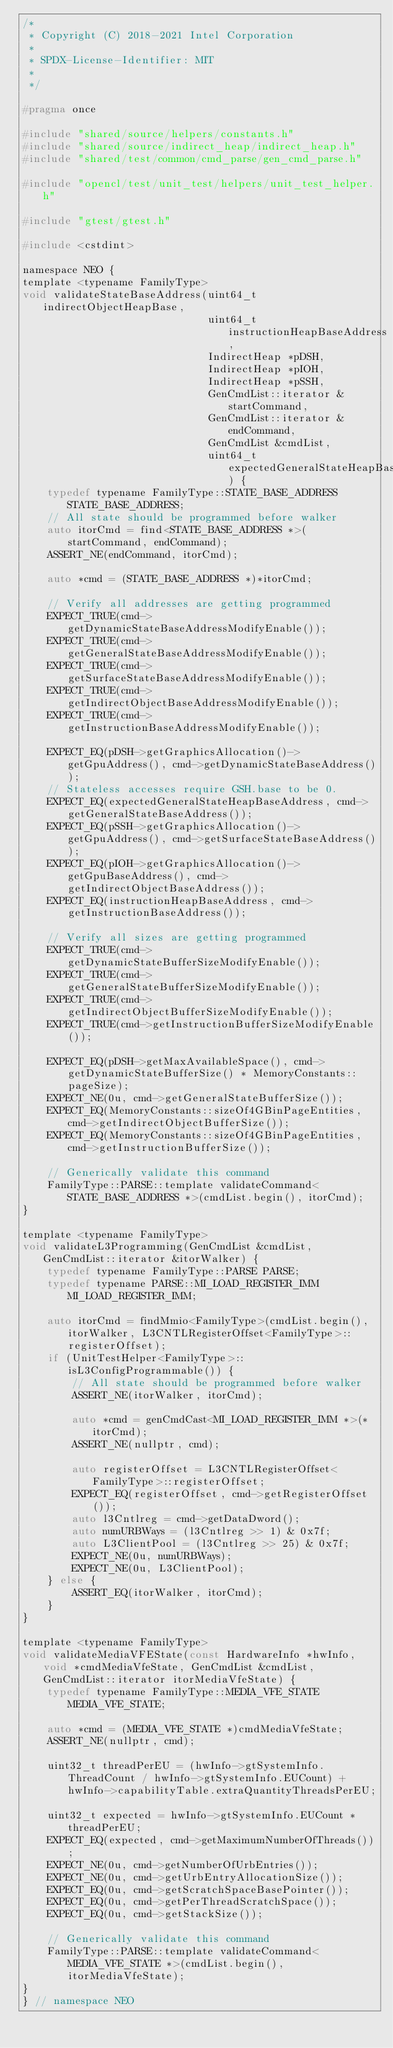<code> <loc_0><loc_0><loc_500><loc_500><_C_>/*
 * Copyright (C) 2018-2021 Intel Corporation
 *
 * SPDX-License-Identifier: MIT
 *
 */

#pragma once

#include "shared/source/helpers/constants.h"
#include "shared/source/indirect_heap/indirect_heap.h"
#include "shared/test/common/cmd_parse/gen_cmd_parse.h"

#include "opencl/test/unit_test/helpers/unit_test_helper.h"

#include "gtest/gtest.h"

#include <cstdint>

namespace NEO {
template <typename FamilyType>
void validateStateBaseAddress(uint64_t indirectObjectHeapBase,
                              uint64_t instructionHeapBaseAddress,
                              IndirectHeap *pDSH,
                              IndirectHeap *pIOH,
                              IndirectHeap *pSSH,
                              GenCmdList::iterator &startCommand,
                              GenCmdList::iterator &endCommand,
                              GenCmdList &cmdList,
                              uint64_t expectedGeneralStateHeapBaseAddress) {
    typedef typename FamilyType::STATE_BASE_ADDRESS STATE_BASE_ADDRESS;
    // All state should be programmed before walker
    auto itorCmd = find<STATE_BASE_ADDRESS *>(startCommand, endCommand);
    ASSERT_NE(endCommand, itorCmd);

    auto *cmd = (STATE_BASE_ADDRESS *)*itorCmd;

    // Verify all addresses are getting programmed
    EXPECT_TRUE(cmd->getDynamicStateBaseAddressModifyEnable());
    EXPECT_TRUE(cmd->getGeneralStateBaseAddressModifyEnable());
    EXPECT_TRUE(cmd->getSurfaceStateBaseAddressModifyEnable());
    EXPECT_TRUE(cmd->getIndirectObjectBaseAddressModifyEnable());
    EXPECT_TRUE(cmd->getInstructionBaseAddressModifyEnable());

    EXPECT_EQ(pDSH->getGraphicsAllocation()->getGpuAddress(), cmd->getDynamicStateBaseAddress());
    // Stateless accesses require GSH.base to be 0.
    EXPECT_EQ(expectedGeneralStateHeapBaseAddress, cmd->getGeneralStateBaseAddress());
    EXPECT_EQ(pSSH->getGraphicsAllocation()->getGpuAddress(), cmd->getSurfaceStateBaseAddress());
    EXPECT_EQ(pIOH->getGraphicsAllocation()->getGpuBaseAddress(), cmd->getIndirectObjectBaseAddress());
    EXPECT_EQ(instructionHeapBaseAddress, cmd->getInstructionBaseAddress());

    // Verify all sizes are getting programmed
    EXPECT_TRUE(cmd->getDynamicStateBufferSizeModifyEnable());
    EXPECT_TRUE(cmd->getGeneralStateBufferSizeModifyEnable());
    EXPECT_TRUE(cmd->getIndirectObjectBufferSizeModifyEnable());
    EXPECT_TRUE(cmd->getInstructionBufferSizeModifyEnable());

    EXPECT_EQ(pDSH->getMaxAvailableSpace(), cmd->getDynamicStateBufferSize() * MemoryConstants::pageSize);
    EXPECT_NE(0u, cmd->getGeneralStateBufferSize());
    EXPECT_EQ(MemoryConstants::sizeOf4GBinPageEntities, cmd->getIndirectObjectBufferSize());
    EXPECT_EQ(MemoryConstants::sizeOf4GBinPageEntities, cmd->getInstructionBufferSize());

    // Generically validate this command
    FamilyType::PARSE::template validateCommand<STATE_BASE_ADDRESS *>(cmdList.begin(), itorCmd);
}

template <typename FamilyType>
void validateL3Programming(GenCmdList &cmdList, GenCmdList::iterator &itorWalker) {
    typedef typename FamilyType::PARSE PARSE;
    typedef typename PARSE::MI_LOAD_REGISTER_IMM MI_LOAD_REGISTER_IMM;

    auto itorCmd = findMmio<FamilyType>(cmdList.begin(), itorWalker, L3CNTLRegisterOffset<FamilyType>::registerOffset);
    if (UnitTestHelper<FamilyType>::isL3ConfigProgrammable()) {
        // All state should be programmed before walker
        ASSERT_NE(itorWalker, itorCmd);

        auto *cmd = genCmdCast<MI_LOAD_REGISTER_IMM *>(*itorCmd);
        ASSERT_NE(nullptr, cmd);

        auto registerOffset = L3CNTLRegisterOffset<FamilyType>::registerOffset;
        EXPECT_EQ(registerOffset, cmd->getRegisterOffset());
        auto l3Cntlreg = cmd->getDataDword();
        auto numURBWays = (l3Cntlreg >> 1) & 0x7f;
        auto L3ClientPool = (l3Cntlreg >> 25) & 0x7f;
        EXPECT_NE(0u, numURBWays);
        EXPECT_NE(0u, L3ClientPool);
    } else {
        ASSERT_EQ(itorWalker, itorCmd);
    }
}

template <typename FamilyType>
void validateMediaVFEState(const HardwareInfo *hwInfo, void *cmdMediaVfeState, GenCmdList &cmdList, GenCmdList::iterator itorMediaVfeState) {
    typedef typename FamilyType::MEDIA_VFE_STATE MEDIA_VFE_STATE;

    auto *cmd = (MEDIA_VFE_STATE *)cmdMediaVfeState;
    ASSERT_NE(nullptr, cmd);

    uint32_t threadPerEU = (hwInfo->gtSystemInfo.ThreadCount / hwInfo->gtSystemInfo.EUCount) + hwInfo->capabilityTable.extraQuantityThreadsPerEU;

    uint32_t expected = hwInfo->gtSystemInfo.EUCount * threadPerEU;
    EXPECT_EQ(expected, cmd->getMaximumNumberOfThreads());
    EXPECT_NE(0u, cmd->getNumberOfUrbEntries());
    EXPECT_NE(0u, cmd->getUrbEntryAllocationSize());
    EXPECT_EQ(0u, cmd->getScratchSpaceBasePointer());
    EXPECT_EQ(0u, cmd->getPerThreadScratchSpace());
    EXPECT_EQ(0u, cmd->getStackSize());

    // Generically validate this command
    FamilyType::PARSE::template validateCommand<MEDIA_VFE_STATE *>(cmdList.begin(), itorMediaVfeState);
}
} // namespace NEO
</code> 